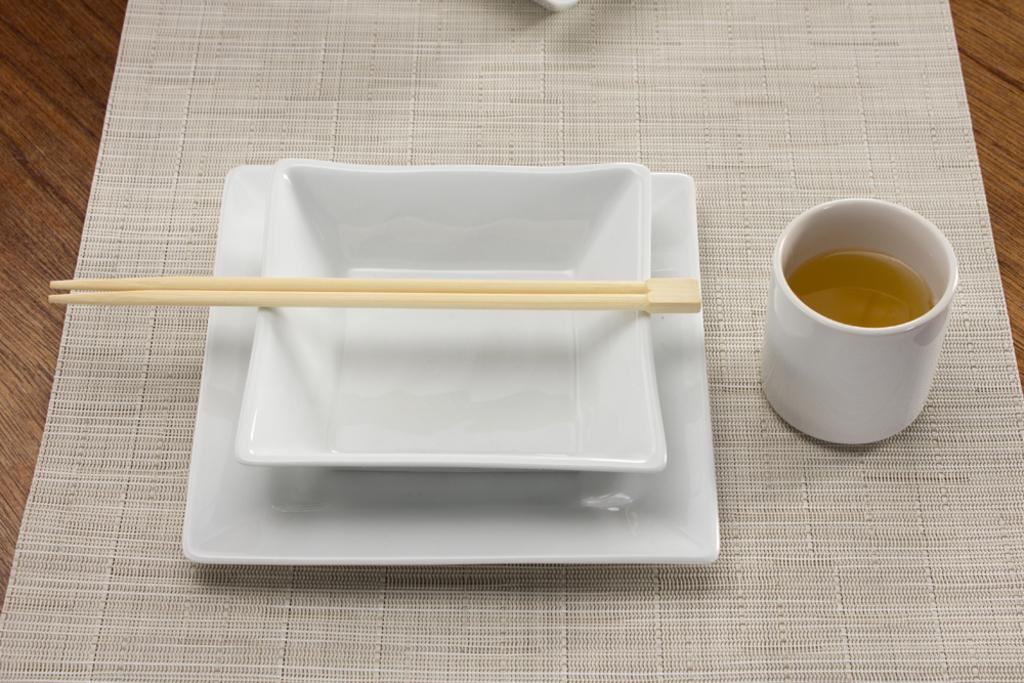How many plates can be seen in the image? There are two plates in the image. What utensil is visible in the image? Chopsticks are visible in the image. What type of beverage might be in the cup in the image? There is a cup of drink in the image, but the specific type of beverage is not mentioned. What is placed on the table in the image? There is a table mat on the table in the image. What type of pen is being used to draw on the fish in the image? There is no pen or fish present in the image. What kind of apparatus is being used to cook the fish in the image? There is no apparatus or fish present in the image. 